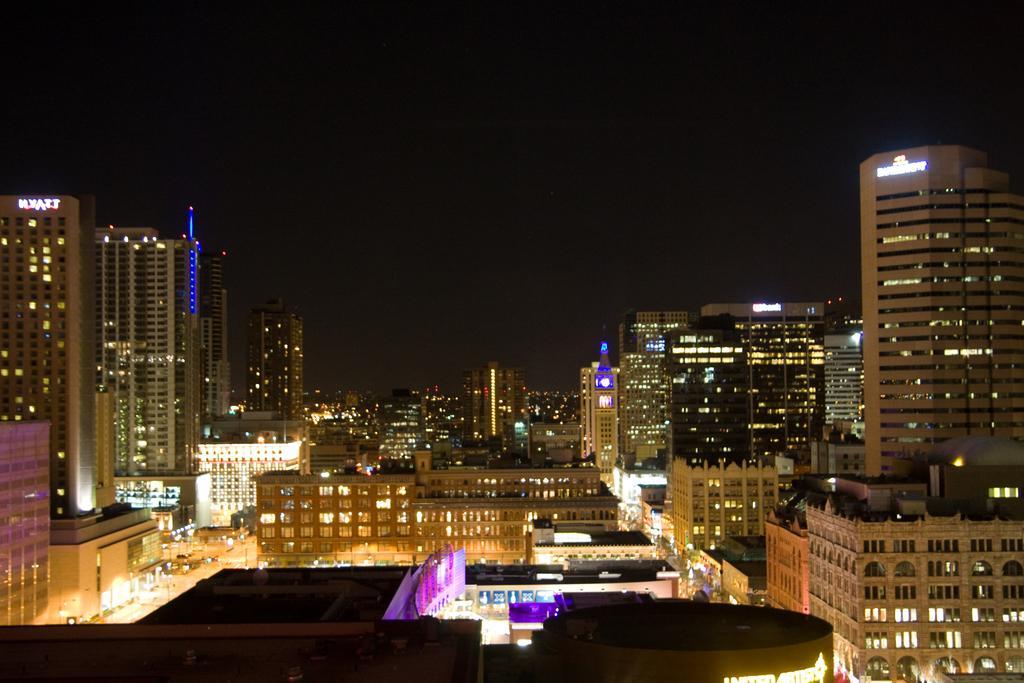Could you give a brief overview of what you see in this image? In the image we can see there are buildings and we can see the windows of the buildings. Here we can see lights, LED text and the dark sky. 